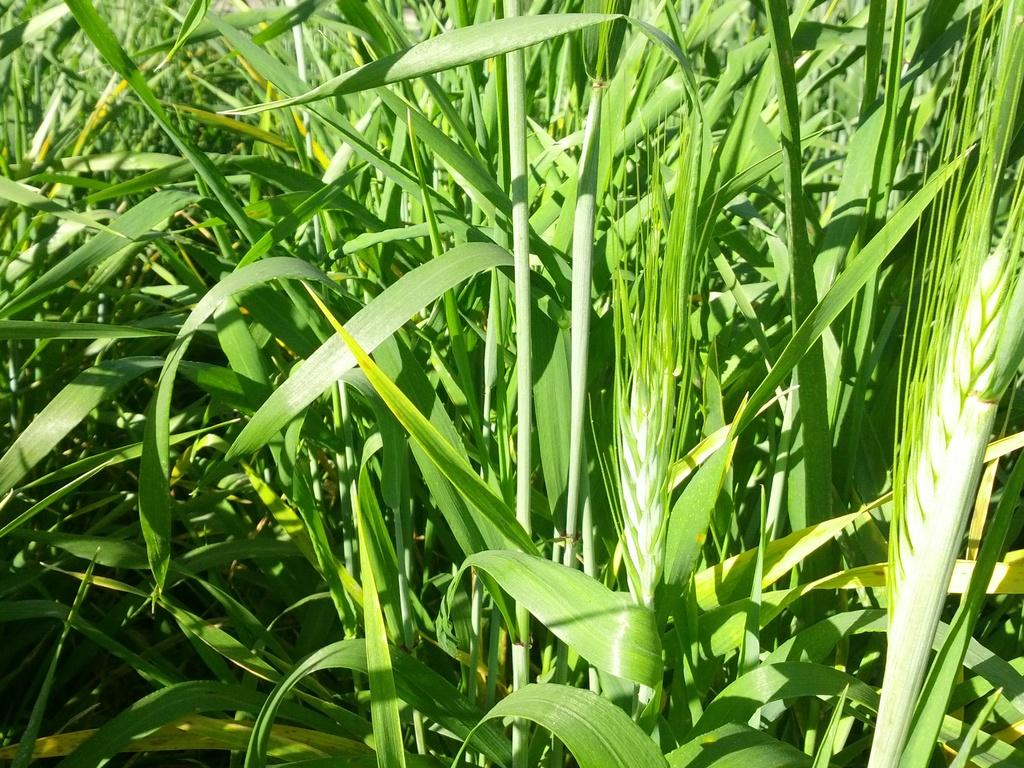What type of vegetation is visible in the image? There is grass in the image. What language is being discussed in the image? There is no discussion or language present in the image; it only features grass. 